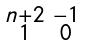<formula> <loc_0><loc_0><loc_500><loc_500>\begin{smallmatrix} n + 2 & - 1 \\ 1 & 0 \end{smallmatrix}</formula> 